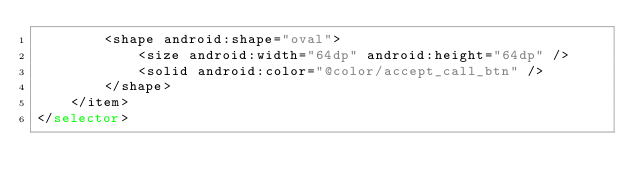<code> <loc_0><loc_0><loc_500><loc_500><_XML_>        <shape android:shape="oval">
            <size android:width="64dp" android:height="64dp" />
            <solid android:color="@color/accept_call_btn" />
        </shape>
    </item>
</selector></code> 